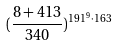Convert formula to latex. <formula><loc_0><loc_0><loc_500><loc_500>( \frac { 8 + 4 1 3 } { 3 4 0 } ) ^ { 1 9 1 ^ { 9 } \cdot 1 6 3 }</formula> 